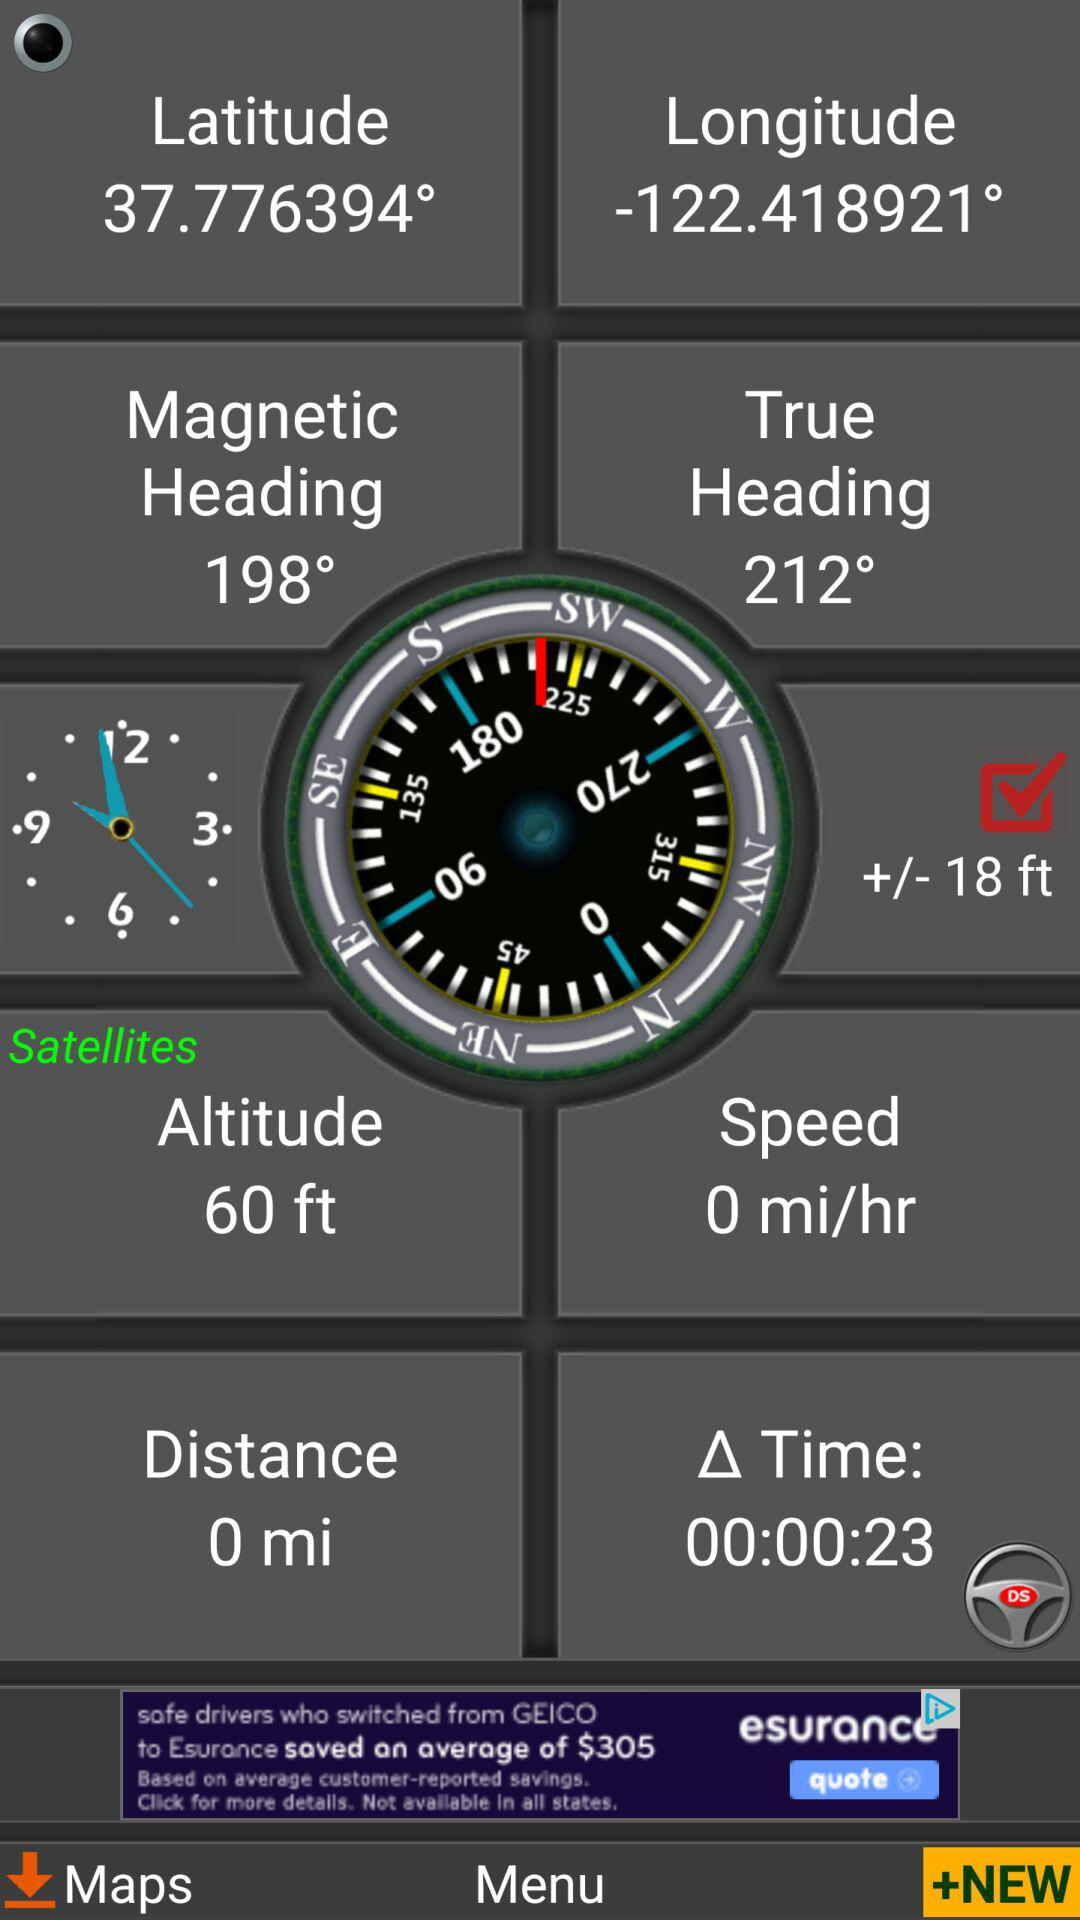What is the distance? The distance is 0 miles. 